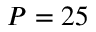Convert formula to latex. <formula><loc_0><loc_0><loc_500><loc_500>P = 2 5</formula> 